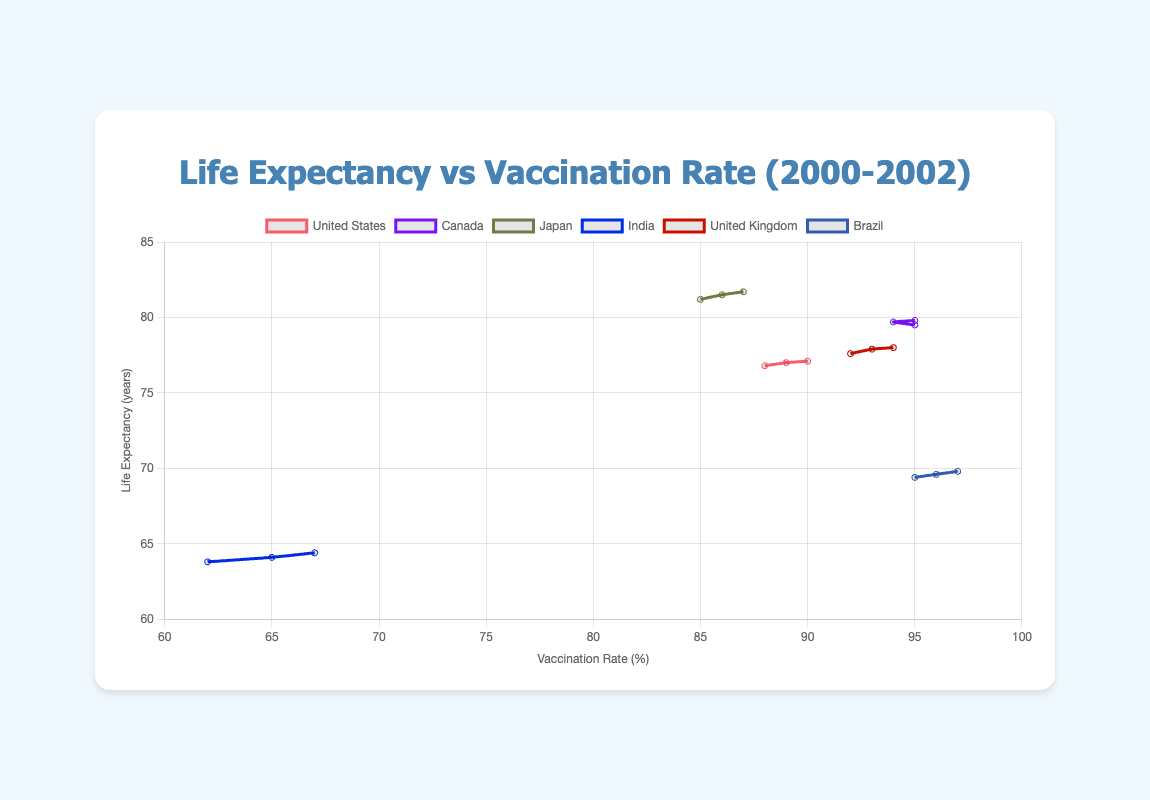Which country had the highest vaccination rate in 2002? In the figure, look for the year 2002 and compare the vaccination rates for all countries. The highest value is for Brazil with a rate of 97%.
Answer: Brazil Which country showed the largest increase in life expectancy from 2000 to 2002? Calculate the difference in life expectancy from 2000 to 2002 for each country (2002 value - 2000 value). Japan had the most significant increase (81.7 - 81.2 = 0.5 years).
Answer: Japan Which country had the lowest life expectancy in 2001? Check the life expectancy values for the year 2001 across all countries. The lowest value for that year is in India with 64.1 years.
Answer: India What is the average life expectancy across all countries in 2000? Sum up the life expectancy values for all countries in 2000 and divide by the number of countries (76.8 + 79.5 + 81.2 + 63.8 + 77.6 + 69.4) / 6 = 74.72 years.
Answer: 74.72 years Is the vaccination rate consistently increasing for the United States from 2000 to 2002? Check the vaccination rate values for the United States; they are 88 in 2000, 89 in 2001, and 90 in 2002, showing a consistent increase.
Answer: Yes What is the average vaccination rate for India over the years 2000 to 2002? Calculate the mean of the vaccination rates for India (62 + 65 + 67) / 3 = 64.67%.
Answer: 64.67% Which country has the steepest slope in the vaccination rate from 2000 to 2002? Compare the slope (rate of increase) in the vaccination rate over the years 2000 to 2002. The United States increased by (90 - 88) = 2 units, Canada by (95 - 94) = 1 unit, Japan by (87 - 85) = 2 units, India by (67 - 62) = 5 units, the United Kingdom by (94 - 92) = 2 units, and Brazil by (97 - 95) = 2 units. India has the steepest increase with 5 units.
Answer: India Compare the life expectancy of Brazil and Canada in 2002. Which country had a higher value? Check the life expectancy values for both Brazil and Canada in 2002. Brazil's value is 69.8 years, while Canada's value is 79.8 years. Therefore, Canada has a higher life expectancy in 2002.
Answer: Canada 